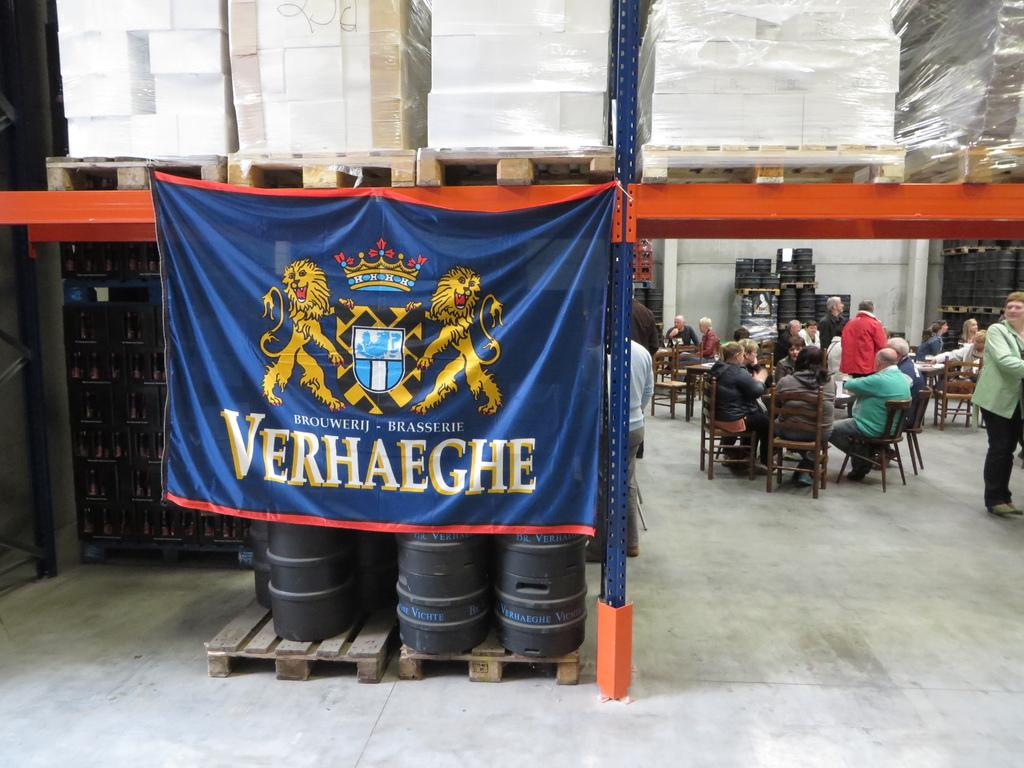What can be seen hanging or displayed in the image? There is a banner in the image. What are the people in the image doing? There is a group of people sitting on chairs, and two people are standing in the image. What musical instruments are visible in the image? There are drums visible in the image. How many eggs are being used as chairs in the image? There are no eggs being used as chairs in the image; the people are sitting on regular chairs. What religious belief is being practiced in the image? There is no indication of any religious belief being practiced in the image. 